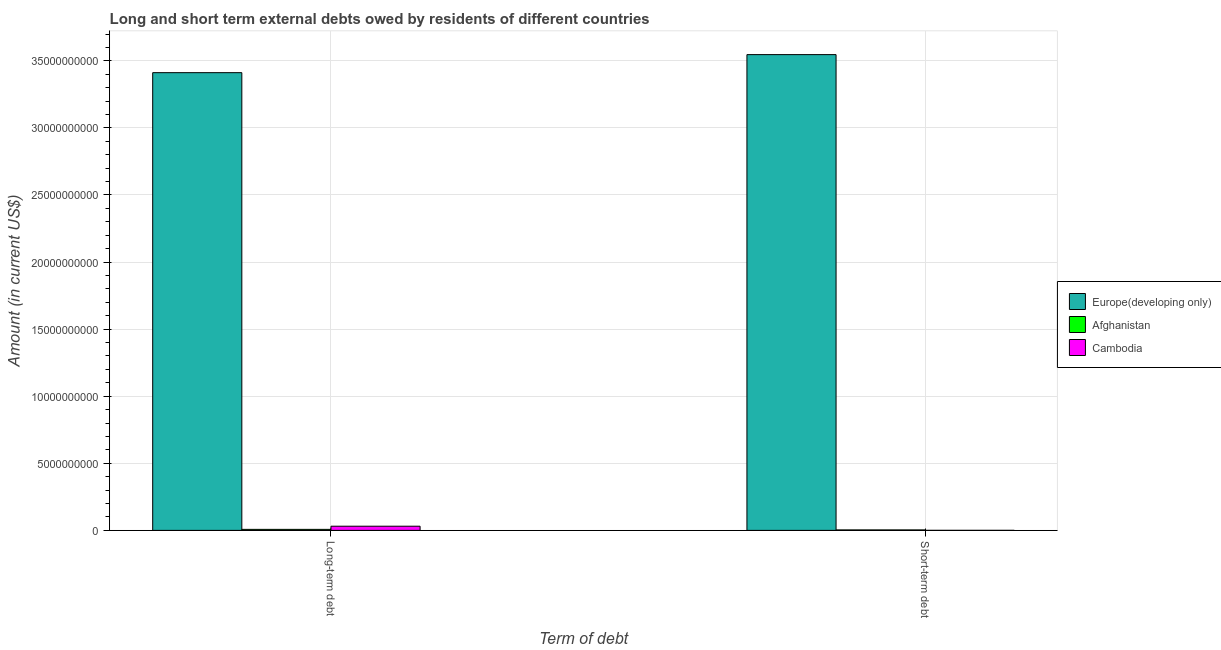How many groups of bars are there?
Your response must be concise. 2. How many bars are there on the 2nd tick from the left?
Give a very brief answer. 3. How many bars are there on the 2nd tick from the right?
Provide a succinct answer. 3. What is the label of the 2nd group of bars from the left?
Provide a succinct answer. Short-term debt. What is the short-term debts owed by residents in Europe(developing only)?
Provide a short and direct response. 3.55e+1. Across all countries, what is the maximum long-term debts owed by residents?
Offer a very short reply. 3.41e+1. Across all countries, what is the minimum short-term debts owed by residents?
Keep it short and to the point. 2.00e+06. In which country was the long-term debts owed by residents maximum?
Make the answer very short. Europe(developing only). In which country was the long-term debts owed by residents minimum?
Offer a very short reply. Afghanistan. What is the total long-term debts owed by residents in the graph?
Give a very brief answer. 3.45e+1. What is the difference between the long-term debts owed by residents in Cambodia and that in Afghanistan?
Your response must be concise. 2.36e+08. What is the difference between the long-term debts owed by residents in Cambodia and the short-term debts owed by residents in Europe(developing only)?
Your response must be concise. -3.52e+1. What is the average long-term debts owed by residents per country?
Your answer should be compact. 1.15e+1. What is the difference between the long-term debts owed by residents and short-term debts owed by residents in Europe(developing only)?
Offer a terse response. -1.35e+09. What is the ratio of the long-term debts owed by residents in Cambodia to that in Europe(developing only)?
Make the answer very short. 0.01. Is the long-term debts owed by residents in Europe(developing only) less than that in Cambodia?
Offer a terse response. No. What does the 3rd bar from the left in Long-term debt represents?
Your answer should be compact. Cambodia. What does the 1st bar from the right in Long-term debt represents?
Offer a very short reply. Cambodia. How many countries are there in the graph?
Your answer should be compact. 3. Does the graph contain any zero values?
Provide a succinct answer. No. Does the graph contain grids?
Offer a terse response. Yes. How many legend labels are there?
Make the answer very short. 3. How are the legend labels stacked?
Your answer should be compact. Vertical. What is the title of the graph?
Your answer should be compact. Long and short term external debts owed by residents of different countries. Does "Greenland" appear as one of the legend labels in the graph?
Ensure brevity in your answer.  No. What is the label or title of the X-axis?
Provide a succinct answer. Term of debt. What is the Amount (in current US$) in Europe(developing only) in Long-term debt?
Make the answer very short. 3.41e+1. What is the Amount (in current US$) of Afghanistan in Long-term debt?
Provide a succinct answer. 7.50e+07. What is the Amount (in current US$) of Cambodia in Long-term debt?
Offer a terse response. 3.11e+08. What is the Amount (in current US$) in Europe(developing only) in Short-term debt?
Ensure brevity in your answer.  3.55e+1. What is the Amount (in current US$) of Afghanistan in Short-term debt?
Provide a short and direct response. 3.50e+07. Across all Term of debt, what is the maximum Amount (in current US$) of Europe(developing only)?
Offer a very short reply. 3.55e+1. Across all Term of debt, what is the maximum Amount (in current US$) of Afghanistan?
Make the answer very short. 7.50e+07. Across all Term of debt, what is the maximum Amount (in current US$) of Cambodia?
Provide a succinct answer. 3.11e+08. Across all Term of debt, what is the minimum Amount (in current US$) of Europe(developing only)?
Provide a succinct answer. 3.41e+1. Across all Term of debt, what is the minimum Amount (in current US$) in Afghanistan?
Give a very brief answer. 3.50e+07. Across all Term of debt, what is the minimum Amount (in current US$) in Cambodia?
Provide a succinct answer. 2.00e+06. What is the total Amount (in current US$) of Europe(developing only) in the graph?
Give a very brief answer. 6.96e+1. What is the total Amount (in current US$) of Afghanistan in the graph?
Offer a very short reply. 1.10e+08. What is the total Amount (in current US$) in Cambodia in the graph?
Provide a succinct answer. 3.13e+08. What is the difference between the Amount (in current US$) in Europe(developing only) in Long-term debt and that in Short-term debt?
Offer a very short reply. -1.35e+09. What is the difference between the Amount (in current US$) of Afghanistan in Long-term debt and that in Short-term debt?
Make the answer very short. 4.00e+07. What is the difference between the Amount (in current US$) in Cambodia in Long-term debt and that in Short-term debt?
Your response must be concise. 3.09e+08. What is the difference between the Amount (in current US$) of Europe(developing only) in Long-term debt and the Amount (in current US$) of Afghanistan in Short-term debt?
Your answer should be compact. 3.41e+1. What is the difference between the Amount (in current US$) of Europe(developing only) in Long-term debt and the Amount (in current US$) of Cambodia in Short-term debt?
Your answer should be very brief. 3.41e+1. What is the difference between the Amount (in current US$) in Afghanistan in Long-term debt and the Amount (in current US$) in Cambodia in Short-term debt?
Your response must be concise. 7.30e+07. What is the average Amount (in current US$) in Europe(developing only) per Term of debt?
Offer a very short reply. 3.48e+1. What is the average Amount (in current US$) of Afghanistan per Term of debt?
Your response must be concise. 5.50e+07. What is the average Amount (in current US$) of Cambodia per Term of debt?
Offer a very short reply. 1.56e+08. What is the difference between the Amount (in current US$) in Europe(developing only) and Amount (in current US$) in Afghanistan in Long-term debt?
Offer a terse response. 3.40e+1. What is the difference between the Amount (in current US$) of Europe(developing only) and Amount (in current US$) of Cambodia in Long-term debt?
Offer a terse response. 3.38e+1. What is the difference between the Amount (in current US$) in Afghanistan and Amount (in current US$) in Cambodia in Long-term debt?
Provide a succinct answer. -2.36e+08. What is the difference between the Amount (in current US$) of Europe(developing only) and Amount (in current US$) of Afghanistan in Short-term debt?
Keep it short and to the point. 3.54e+1. What is the difference between the Amount (in current US$) of Europe(developing only) and Amount (in current US$) of Cambodia in Short-term debt?
Offer a terse response. 3.55e+1. What is the difference between the Amount (in current US$) in Afghanistan and Amount (in current US$) in Cambodia in Short-term debt?
Ensure brevity in your answer.  3.30e+07. What is the ratio of the Amount (in current US$) in Europe(developing only) in Long-term debt to that in Short-term debt?
Offer a very short reply. 0.96. What is the ratio of the Amount (in current US$) in Afghanistan in Long-term debt to that in Short-term debt?
Ensure brevity in your answer.  2.14. What is the ratio of the Amount (in current US$) of Cambodia in Long-term debt to that in Short-term debt?
Make the answer very short. 155.27. What is the difference between the highest and the second highest Amount (in current US$) of Europe(developing only)?
Your answer should be very brief. 1.35e+09. What is the difference between the highest and the second highest Amount (in current US$) of Afghanistan?
Your response must be concise. 4.00e+07. What is the difference between the highest and the second highest Amount (in current US$) in Cambodia?
Give a very brief answer. 3.09e+08. What is the difference between the highest and the lowest Amount (in current US$) of Europe(developing only)?
Your response must be concise. 1.35e+09. What is the difference between the highest and the lowest Amount (in current US$) in Afghanistan?
Ensure brevity in your answer.  4.00e+07. What is the difference between the highest and the lowest Amount (in current US$) of Cambodia?
Your answer should be very brief. 3.09e+08. 